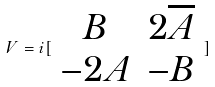<formula> <loc_0><loc_0><loc_500><loc_500>V = i [ \begin{array} { c c } B & 2 \overline { A } \\ - 2 A & - B \end{array} ]</formula> 